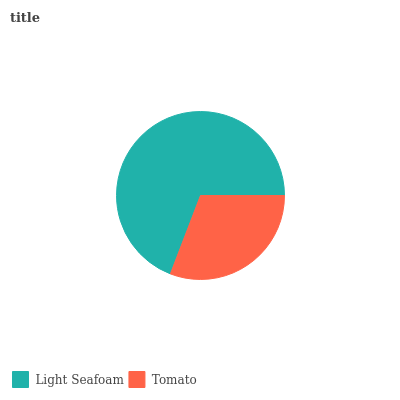Is Tomato the minimum?
Answer yes or no. Yes. Is Light Seafoam the maximum?
Answer yes or no. Yes. Is Tomato the maximum?
Answer yes or no. No. Is Light Seafoam greater than Tomato?
Answer yes or no. Yes. Is Tomato less than Light Seafoam?
Answer yes or no. Yes. Is Tomato greater than Light Seafoam?
Answer yes or no. No. Is Light Seafoam less than Tomato?
Answer yes or no. No. Is Light Seafoam the high median?
Answer yes or no. Yes. Is Tomato the low median?
Answer yes or no. Yes. Is Tomato the high median?
Answer yes or no. No. Is Light Seafoam the low median?
Answer yes or no. No. 